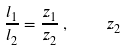Convert formula to latex. <formula><loc_0><loc_0><loc_500><loc_500>\frac { l _ { 1 } } { l _ { 2 } } = \frac { z _ { 1 } } { z _ { 2 } } \, , \quad z _ { 2 }</formula> 